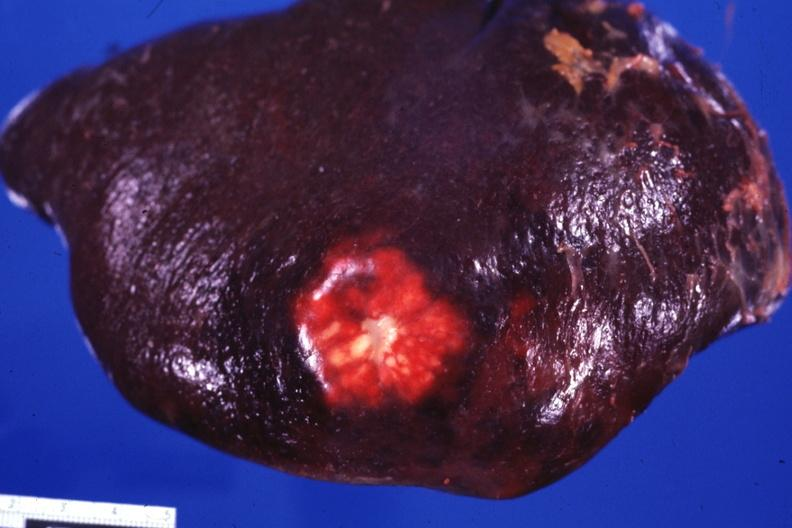s hematologic present?
Answer the question using a single word or phrase. Yes 